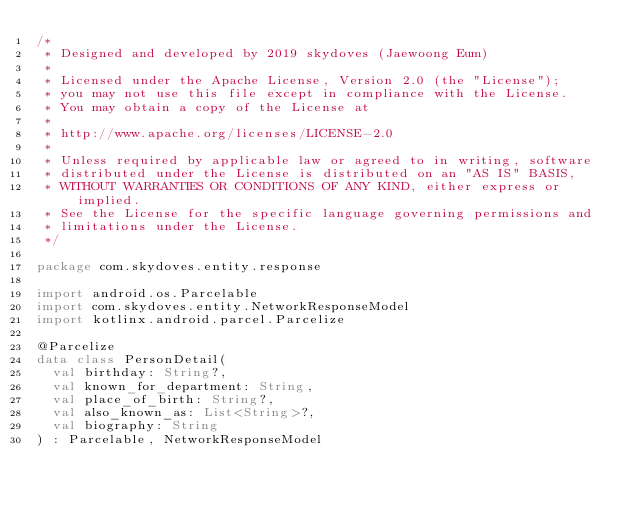Convert code to text. <code><loc_0><loc_0><loc_500><loc_500><_Kotlin_>/*
 * Designed and developed by 2019 skydoves (Jaewoong Eum)
 *
 * Licensed under the Apache License, Version 2.0 (the "License");
 * you may not use this file except in compliance with the License.
 * You may obtain a copy of the License at
 *
 * http://www.apache.org/licenses/LICENSE-2.0
 *
 * Unless required by applicable law or agreed to in writing, software
 * distributed under the License is distributed on an "AS IS" BASIS,
 * WITHOUT WARRANTIES OR CONDITIONS OF ANY KIND, either express or implied.
 * See the License for the specific language governing permissions and
 * limitations under the License.
 */

package com.skydoves.entity.response

import android.os.Parcelable
import com.skydoves.entity.NetworkResponseModel
import kotlinx.android.parcel.Parcelize

@Parcelize
data class PersonDetail(
  val birthday: String?,
  val known_for_department: String,
  val place_of_birth: String?,
  val also_known_as: List<String>?,
  val biography: String
) : Parcelable, NetworkResponseModel
</code> 